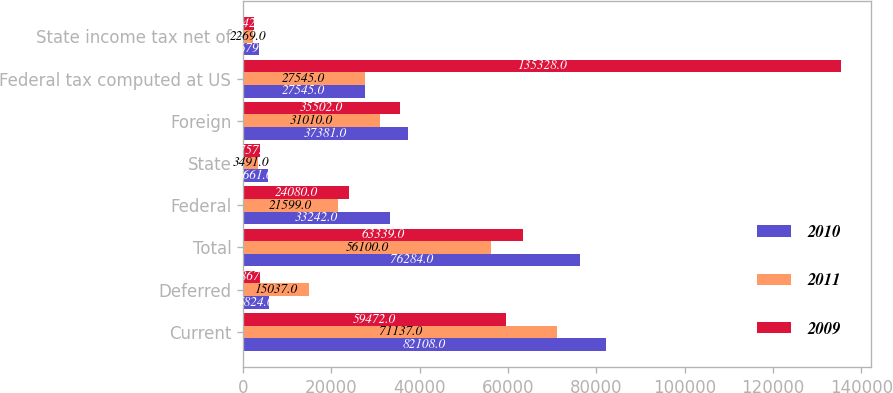Convert chart to OTSL. <chart><loc_0><loc_0><loc_500><loc_500><stacked_bar_chart><ecel><fcel>Current<fcel>Deferred<fcel>Total<fcel>Federal<fcel>State<fcel>Foreign<fcel>Federal tax computed at US<fcel>State income tax net of<nl><fcel>2010<fcel>82108<fcel>5824<fcel>76284<fcel>33242<fcel>5661<fcel>37381<fcel>27545<fcel>3679<nl><fcel>2011<fcel>71137<fcel>15037<fcel>56100<fcel>21599<fcel>3491<fcel>31010<fcel>27545<fcel>2269<nl><fcel>2009<fcel>59472<fcel>3867<fcel>63339<fcel>24080<fcel>3757<fcel>35502<fcel>135328<fcel>2442<nl></chart> 